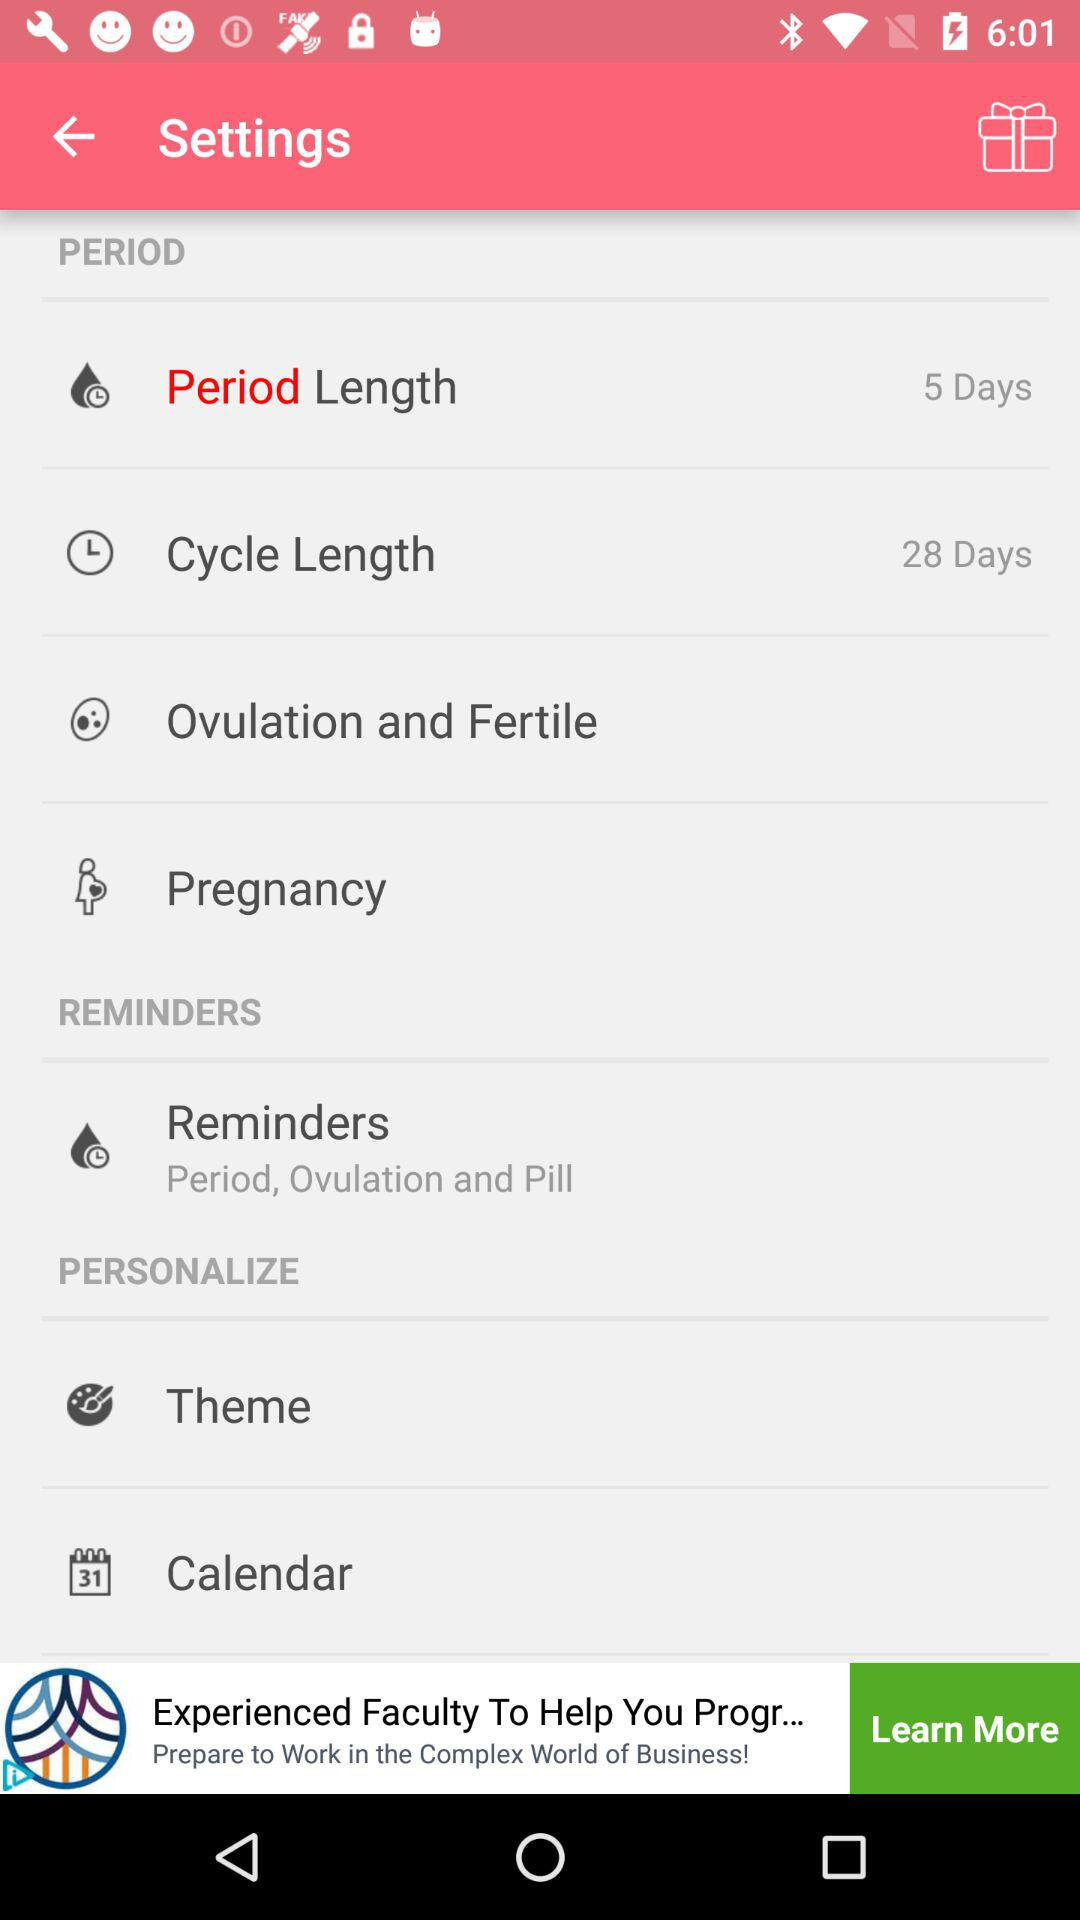How many more days are in the cycle length than the period length?
Answer the question using a single word or phrase. 23 